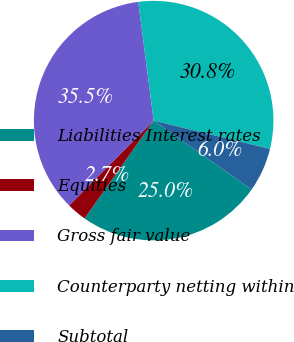Convert chart. <chart><loc_0><loc_0><loc_500><loc_500><pie_chart><fcel>Liabilities Interest rates<fcel>Equities<fcel>Gross fair value<fcel>Counterparty netting within<fcel>Subtotal<nl><fcel>25.04%<fcel>2.68%<fcel>35.48%<fcel>30.84%<fcel>5.96%<nl></chart> 